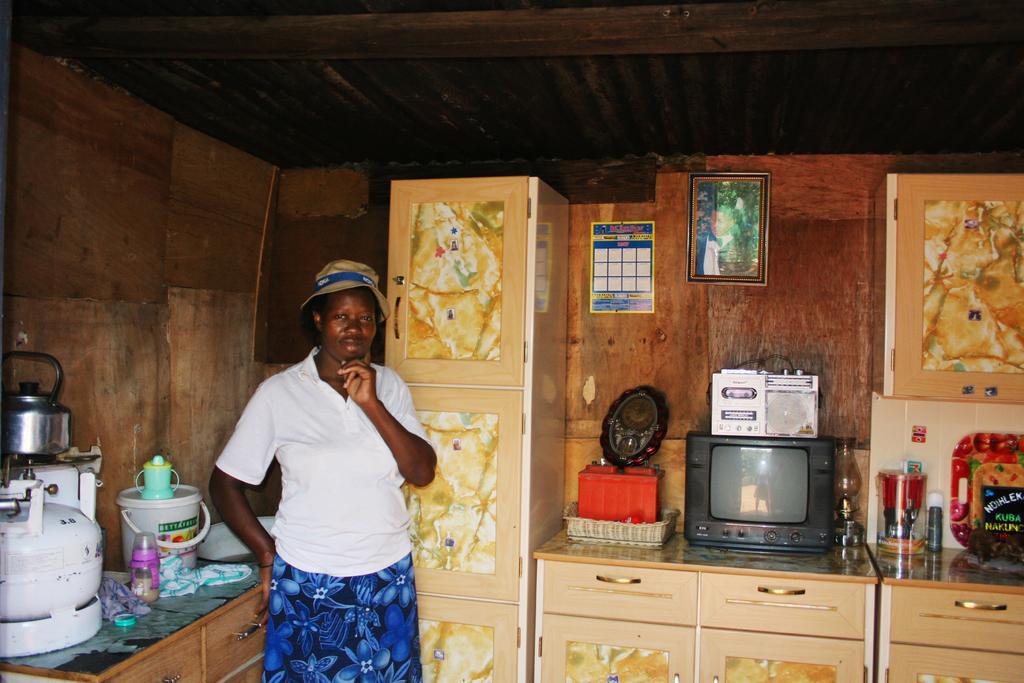In one or two sentences, can you explain what this image depicts? This image is taken indoors. At the top of the image there is a roof. In the background there are a few walls with picture frames and a calendar. On the left side of the image there is a kitchen platform with a cylinder, a stove, a kettle, a bucket and a few things on it. In the middle of the image a woman is standing. On the right side of the image there are a few cupboards and there are two tables with a television and a few objects on it. 